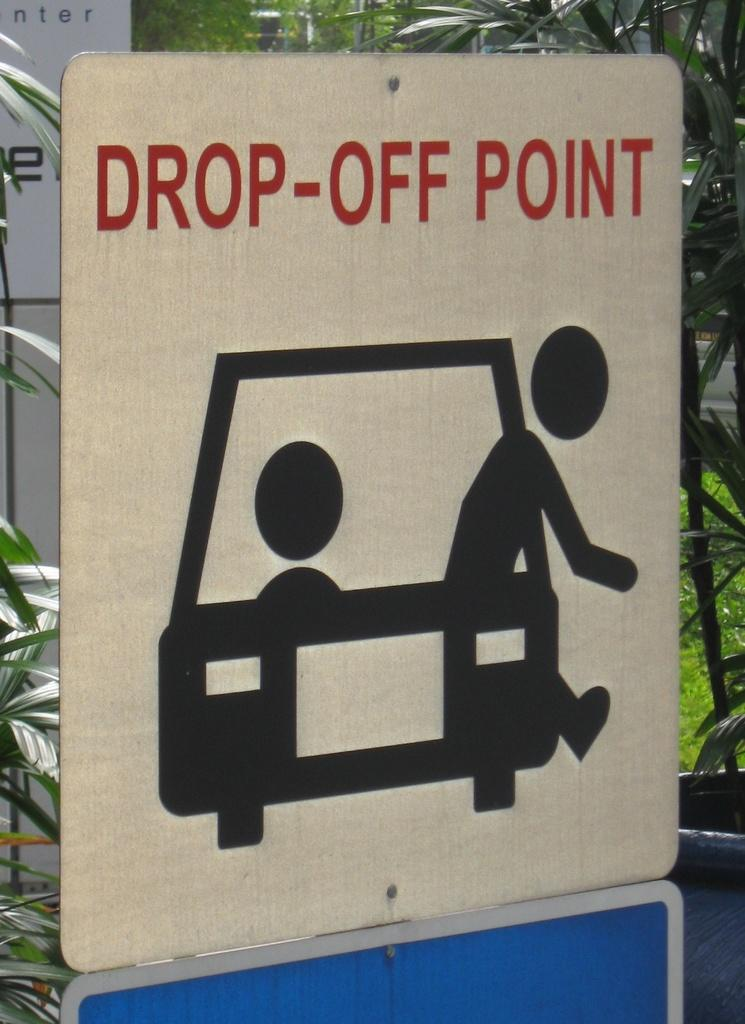Provide a one-sentence caption for the provided image. An illustrated person exits from a car on a drop-off point sign. 